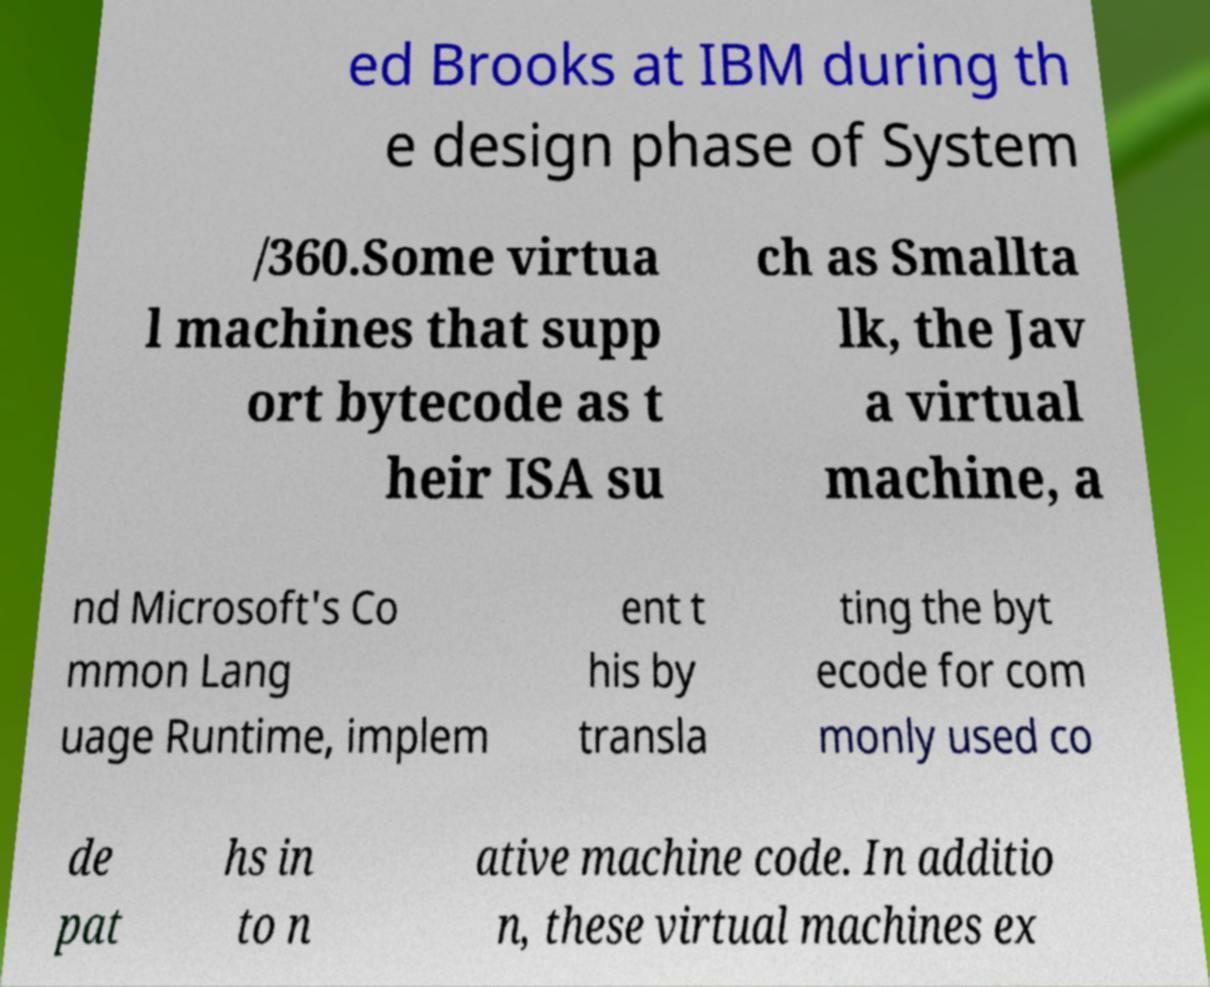Can you accurately transcribe the text from the provided image for me? ed Brooks at IBM during th e design phase of System /360.Some virtua l machines that supp ort bytecode as t heir ISA su ch as Smallta lk, the Jav a virtual machine, a nd Microsoft's Co mmon Lang uage Runtime, implem ent t his by transla ting the byt ecode for com monly used co de pat hs in to n ative machine code. In additio n, these virtual machines ex 